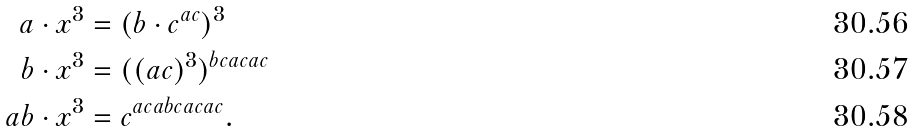Convert formula to latex. <formula><loc_0><loc_0><loc_500><loc_500>a \cdot x ^ { 3 } & = ( b \cdot c ^ { a c } ) ^ { 3 } \\ b \cdot x ^ { 3 } & = ( ( a c ) ^ { 3 } ) ^ { b c a c a c } \\ a b \cdot x ^ { 3 } & = c ^ { a c a b c a c a c } .</formula> 